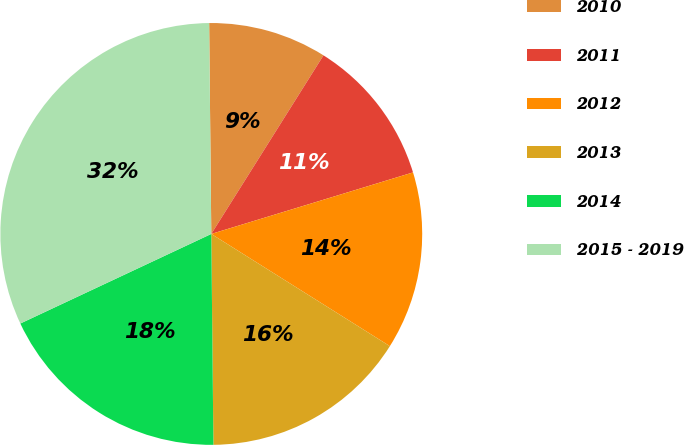Convert chart to OTSL. <chart><loc_0><loc_0><loc_500><loc_500><pie_chart><fcel>2010<fcel>2011<fcel>2012<fcel>2013<fcel>2014<fcel>2015 - 2019<nl><fcel>9.09%<fcel>11.36%<fcel>13.64%<fcel>15.91%<fcel>18.18%<fcel>31.82%<nl></chart> 